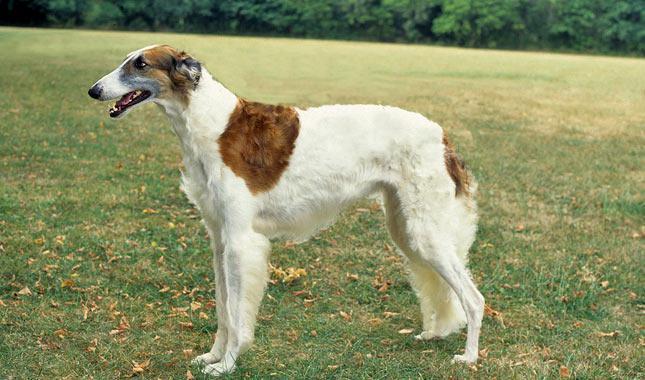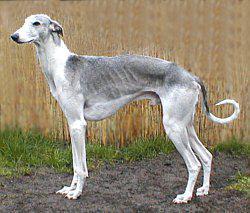The first image is the image on the left, the second image is the image on the right. Assess this claim about the two images: "An image shows a hound with at least its two front paws fully off the ground.". Correct or not? Answer yes or no. No. 